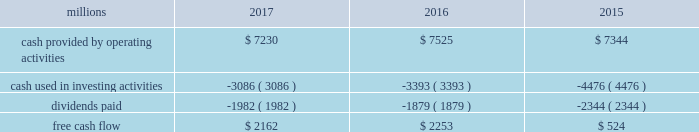Adjusted net income of $ 4.6 billion translated into adjusted earnings of $ 5.79 per diluted share , a best- ever performance .
F0b7 freight revenues 2013 our freight revenues increased 7% ( 7 % ) year-over-year to $ 19.8 billion driven by volume growth of 2% ( 2 % ) , higher fuel surcharge revenue , and core pricing gains .
Growth in frac sand , coal , and intermodal shipments more than offset declines in grain , crude oil , finished vehicles , and rock shipments .
F0b7 fuel prices 2013 our average price of diesel fuel in 2017 was $ 1.81 per gallon , an increase of 22% ( 22 % ) from 2016 , as both crude oil and conversion spreads between crude oil and diesel increased in 2017 .
The higher price resulted in increased operating expenses of $ 334 million ( excluding any impact from year- over-year volume growth ) .
Gross-ton miles increased 5% ( 5 % ) , which also drove higher fuel expense .
Our fuel consumption rate , computed as gallons of fuel consumed divided by gross ton-miles in thousands , improved 2% ( 2 % ) .
F0b7 free cash flow 2013 cash generated by operating activities totaled $ 7.2 billion , yielding free cash flow of $ 2.2 billion after reductions of $ 3.1 billion for cash used in investing activities and $ 2 billion in dividends , which included a 10% ( 10 % ) increase in our quarterly dividend per share from $ 0.605 to $ 0.665 declared and paid in the fourth quarter of 2017 .
Free cash flow is defined as cash provided by operating activities less cash used in investing activities and dividends paid .
Free cash flow is not considered a financial measure under gaap by sec regulation g and item 10 of sec regulation s-k and may not be defined and calculated by other companies in the same manner .
We believe free cash flow is important to management and investors in evaluating our financial performance and measures our ability to generate cash without additional external financings .
Free cash flow should be considered in addition to , rather than as a substitute for , cash provided by operating activities .
The table reconciles cash provided by operating activities ( gaap measure ) to free cash flow ( non-gaap measure ) : .
2018 outlook f0b7 safety 2013 operating a safe railroad benefits all our constituents : our employees , customers , shareholders and the communities we serve .
We will continue using a multi-faceted approach to safety , utilizing technology , risk assessment , training and employee engagement , quality control , and targeted capital investments .
We will continue using and expanding the deployment of total safety culture and courage to care throughout our operations , which allows us to identify and implement best practices for employee and operational safety .
We will continue our efforts to increase detection of rail defects ; improve or close crossings ; and educate the public and law enforcement agencies about crossing safety through a combination of our own programs ( including risk assessment strategies ) , industry programs and local community activities across our network .
F0b7 network operations 2013 in 2018 , we will continue to align resources with customer demand , maintain an efficient network , and ensure surge capability of our assets .
F0b7 fuel prices 2013 fuel price projections for crude oil and natural gas continue to fluctuate in the current environment .
We again could see volatile fuel prices during the year , as they are sensitive to global and u.s .
Domestic demand , refining capacity , geopolitical events , weather conditions and other factors .
As prices fluctuate , there will be a timing impact on earnings , as our fuel surcharge programs trail increases or decreases in fuel price by approximately two months .
Lower fuel prices could have a positive impact on the economy by increasing consumer discretionary spending that potentially could increase demand for various consumer products that we transport .
Alternatively , lower fuel prices could likely have a negative impact on other commodities such as coal and domestic drilling-related shipments. .
What was the percent of the cash generated by operating activities in 2017 that was used for investing activities? 
Computations: (3.1 / 7.2)
Answer: 0.43056. 